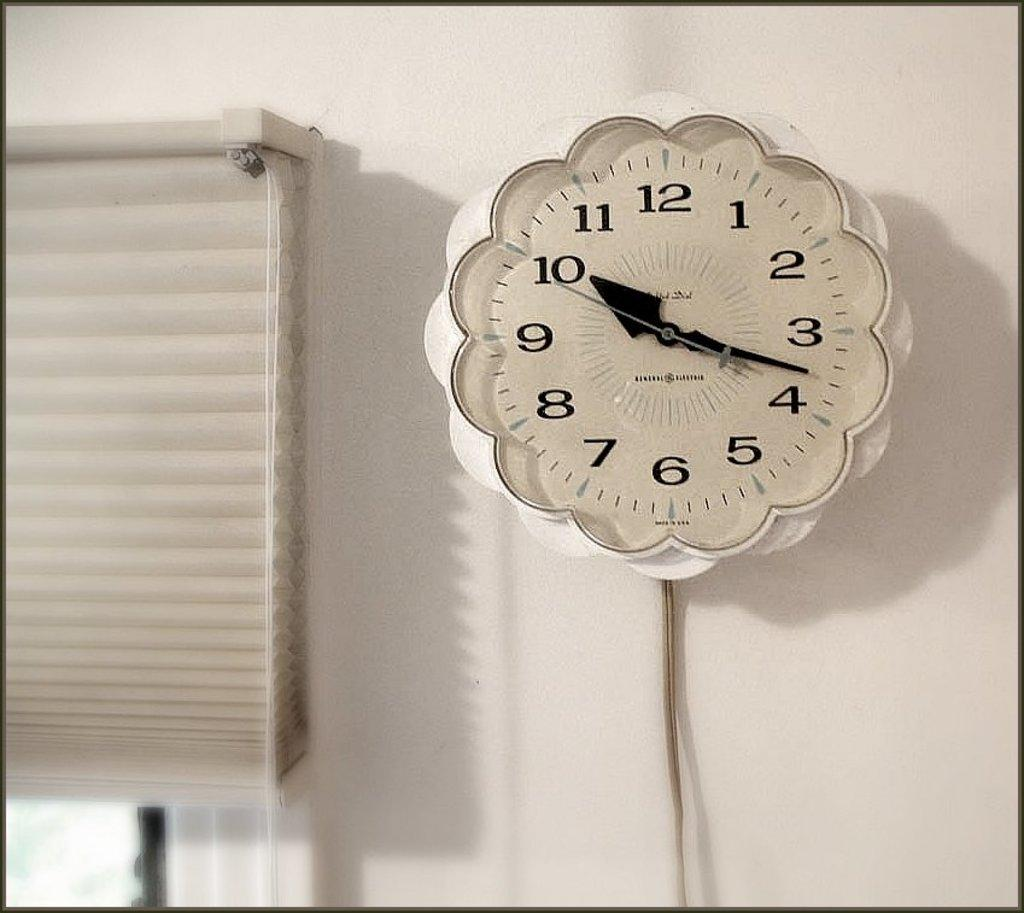<image>
Relay a brief, clear account of the picture shown. A scalloped white analog clock with the numbers 1-12 displayed and Made in USA 